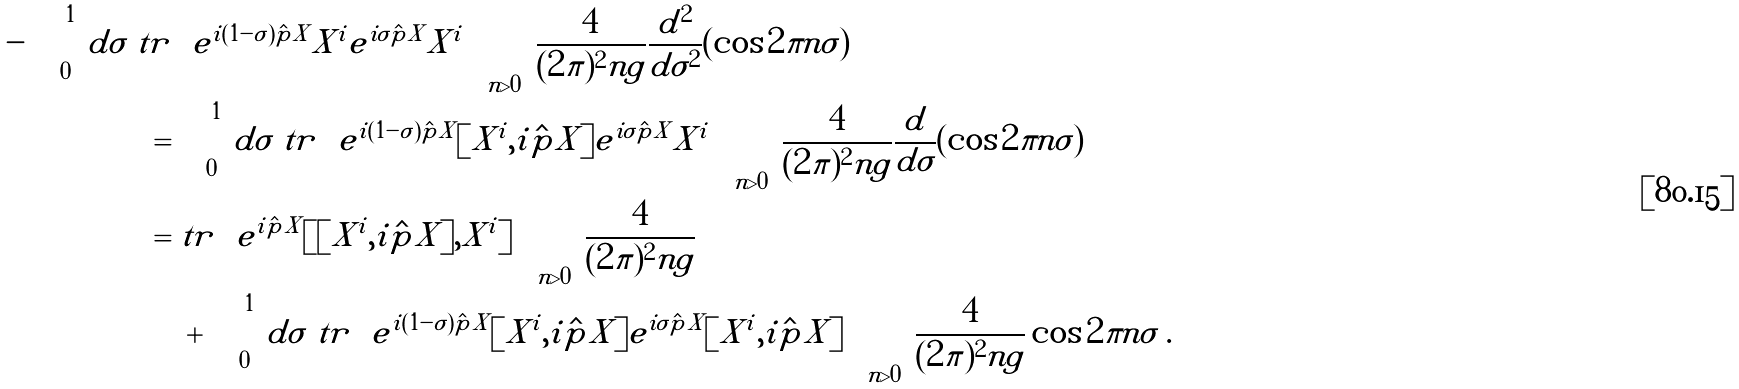Convert formula to latex. <formula><loc_0><loc_0><loc_500><loc_500>- \int _ { 0 } ^ { 1 } \, d \sigma \ t r & \left [ e ^ { i ( 1 - \sigma ) \hat { p } X } X ^ { i } e ^ { i \sigma \hat { p } X } X ^ { i } \right ] \sum _ { n > 0 } \frac { 4 } { ( 2 \pi ) ^ { 2 } n g } \frac { d ^ { 2 } } { d \sigma ^ { 2 } } ( \cos 2 \pi n \sigma ) \\ = & \int _ { 0 } ^ { 1 } \, d \sigma \ t r \left [ e ^ { i ( 1 - \sigma ) \hat { p } X } [ X ^ { i } , i \hat { p } X ] e ^ { i \sigma \hat { p } X } X ^ { i } \right ] \sum _ { n > 0 } \frac { 4 } { ( 2 \pi ) ^ { 2 } n g } \frac { d } { d \sigma } ( \cos 2 \pi n \sigma ) \\ = & \ t r \left [ e ^ { i \hat { p } X } [ [ X ^ { i } , i \hat { p } X ] , X ^ { i } ] \right ] \sum _ { n > 0 } \frac { 4 } { ( 2 \pi ) ^ { 2 } n g } \\ & \ + \int _ { 0 } ^ { 1 } \, d \sigma \ t r \left [ e ^ { i ( 1 - \sigma ) \hat { p } X } [ X ^ { i } , i \hat { p } X ] e ^ { i \sigma \hat { p } X } [ X ^ { i } , i \hat { p } X ] \right ] \sum _ { n > 0 } \frac { 4 } { ( 2 \pi ) ^ { 2 } n g } \cos 2 \pi n \sigma \ .</formula> 